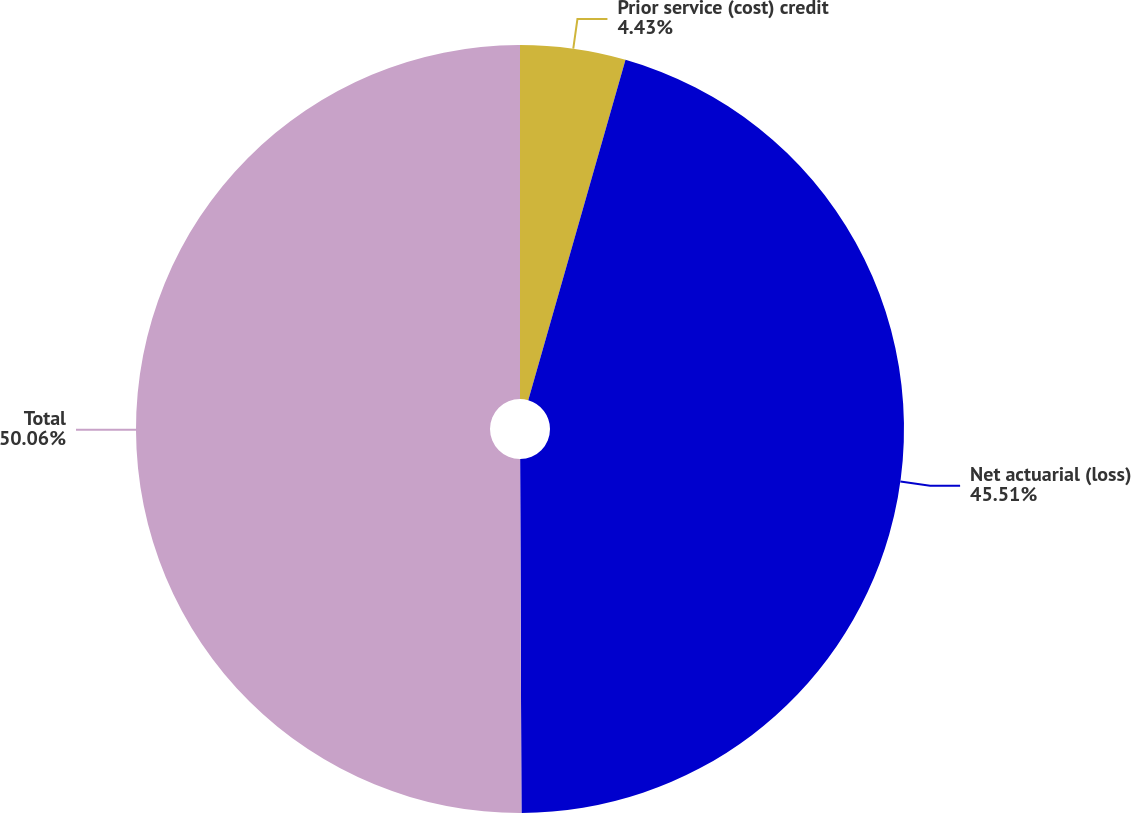<chart> <loc_0><loc_0><loc_500><loc_500><pie_chart><fcel>Prior service (cost) credit<fcel>Net actuarial (loss)<fcel>Total<nl><fcel>4.43%<fcel>45.51%<fcel>50.06%<nl></chart> 